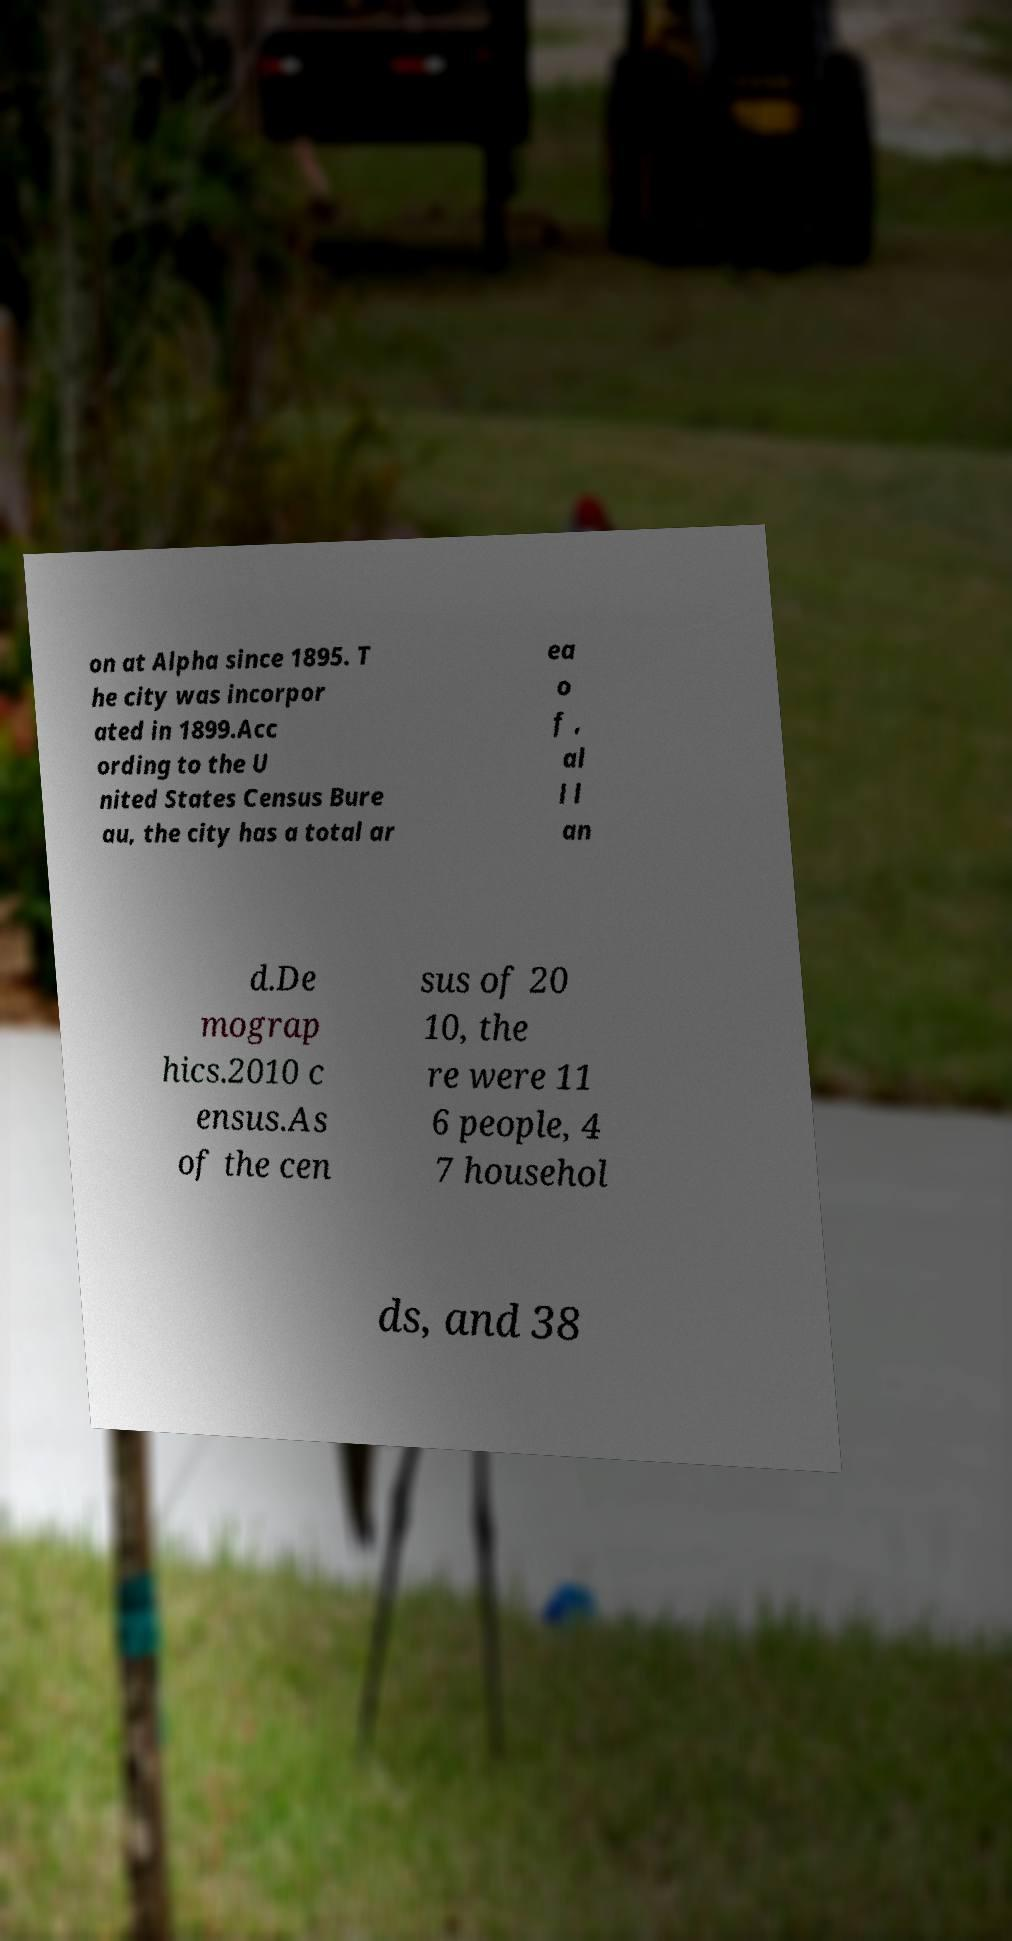Please identify and transcribe the text found in this image. on at Alpha since 1895. T he city was incorpor ated in 1899.Acc ording to the U nited States Census Bure au, the city has a total ar ea o f , al l l an d.De mograp hics.2010 c ensus.As of the cen sus of 20 10, the re were 11 6 people, 4 7 househol ds, and 38 